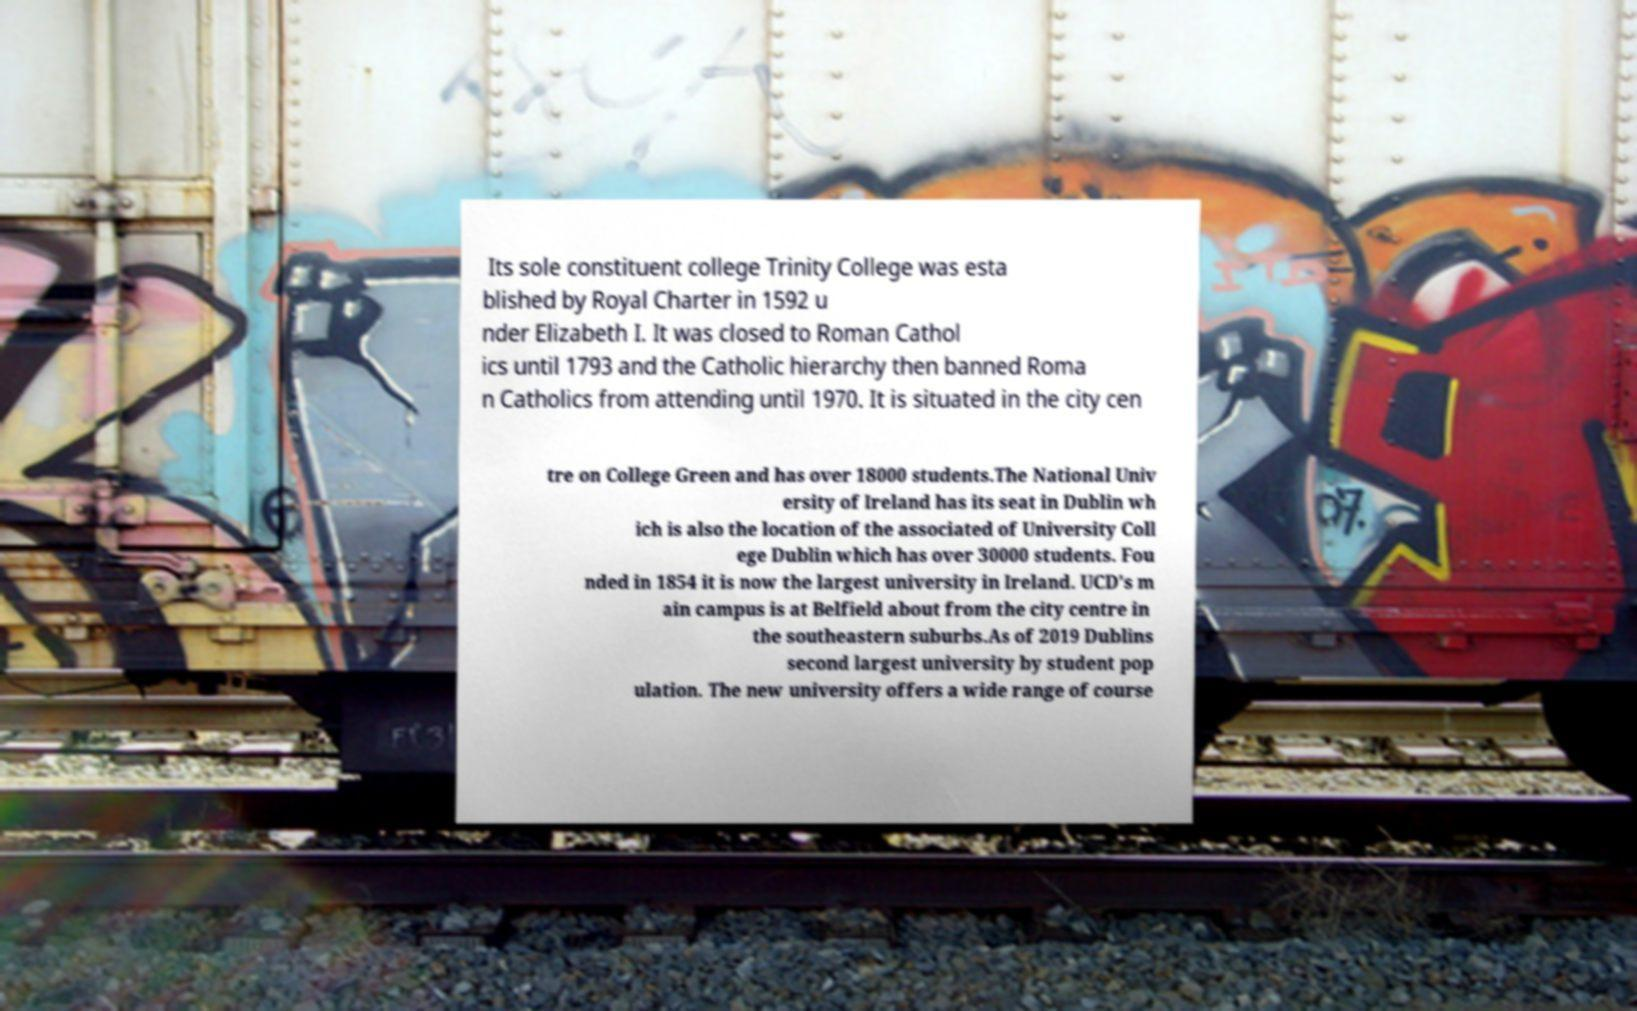For documentation purposes, I need the text within this image transcribed. Could you provide that? Its sole constituent college Trinity College was esta blished by Royal Charter in 1592 u nder Elizabeth I. It was closed to Roman Cathol ics until 1793 and the Catholic hierarchy then banned Roma n Catholics from attending until 1970. It is situated in the city cen tre on College Green and has over 18000 students.The National Univ ersity of Ireland has its seat in Dublin wh ich is also the location of the associated of University Coll ege Dublin which has over 30000 students. Fou nded in 1854 it is now the largest university in Ireland. UCD's m ain campus is at Belfield about from the city centre in the southeastern suburbs.As of 2019 Dublins second largest university by student pop ulation. The new university offers a wide range of course 